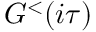<formula> <loc_0><loc_0><loc_500><loc_500>G ^ { < } ( i \tau )</formula> 